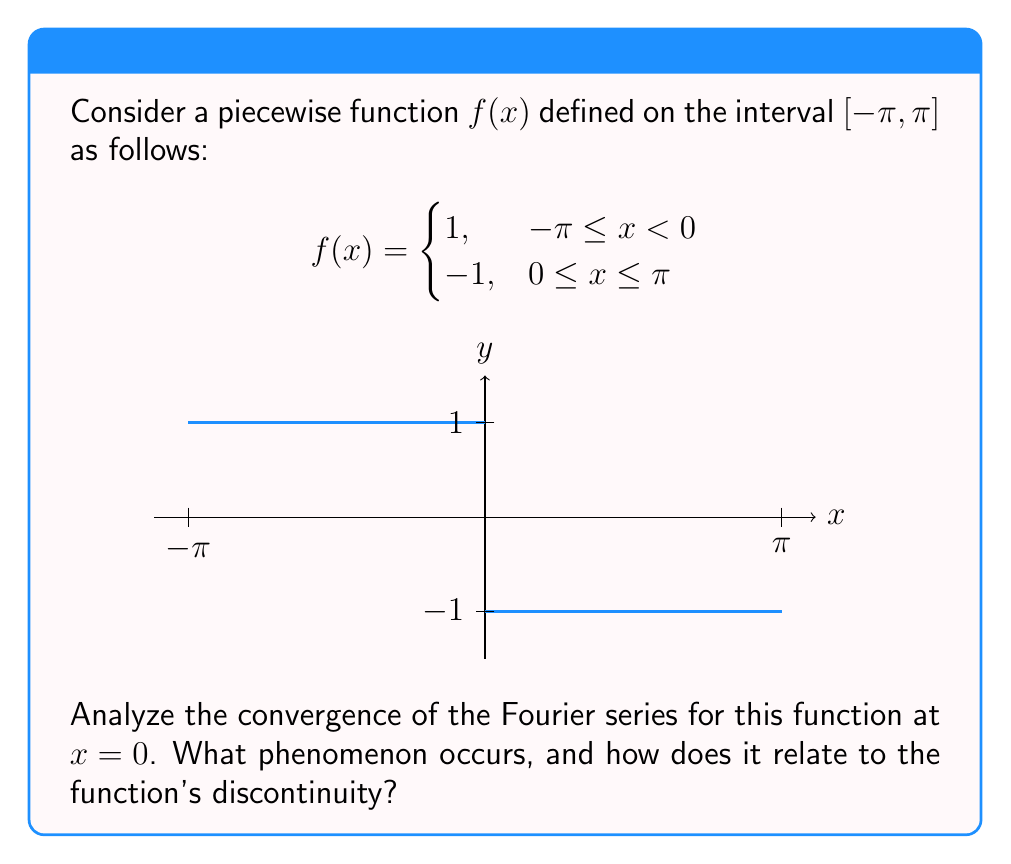Show me your answer to this math problem. To analyze the convergence of the Fourier series for this function at $x = 0$, we'll follow these steps:

1) First, recall the Fourier series for a function $f(x)$ on $[-\pi, \pi]$:

   $$f(x) \sim \frac{a_0}{2} + \sum_{n=1}^{\infty} (a_n \cos(nx) + b_n \sin(nx))$$

   where $a_n = \frac{1}{\pi} \int_{-\pi}^{\pi} f(x) \cos(nx) dx$ and $b_n = \frac{1}{\pi} \int_{-\pi}^{\pi} f(x) \sin(nx) dx$

2) For our piecewise function, due to its odd symmetry, all $a_n$ coefficients (including $a_0$) will be zero.

3) The $b_n$ coefficients can be calculated as:

   $$b_n = \frac{1}{\pi} \int_{-\pi}^{\pi} f(x) \sin(nx) dx = \frac{1}{\pi} \left(\int_{-\pi}^0 \sin(nx) dx - \int_0^{\pi} \sin(nx) dx\right) = \frac{4}{n\pi}$$ for odd $n$, and 0 for even $n$.

4) Therefore, the Fourier series for this function is:

   $$f(x) \sim \frac{4}{\pi} \left(\sin(x) + \frac{1}{3}\sin(3x) + \frac{1}{5}\sin(5x) + ...\right)$$

5) At $x = 0$, all sine terms become zero, so the series converges to 0.

6) However, the original function has a jump discontinuity at $x = 0$, with $f(0^-) = 1$ and $f(0^+) = -1$.

7) This demonstrates the Gibbs phenomenon: the Fourier series converges to the average of the left and right limits at a jump discontinuity.

   $$\frac{f(0^-) + f(0^+)}{2} = \frac{1 + (-1)}{2} = 0$$

8) The Gibbs phenomenon also manifests as overshoots near the discontinuity, which persist even as more terms are added to the series.
Answer: The Fourier series converges to 0 at $x = 0$, exhibiting the Gibbs phenomenon due to the function's jump discontinuity. 